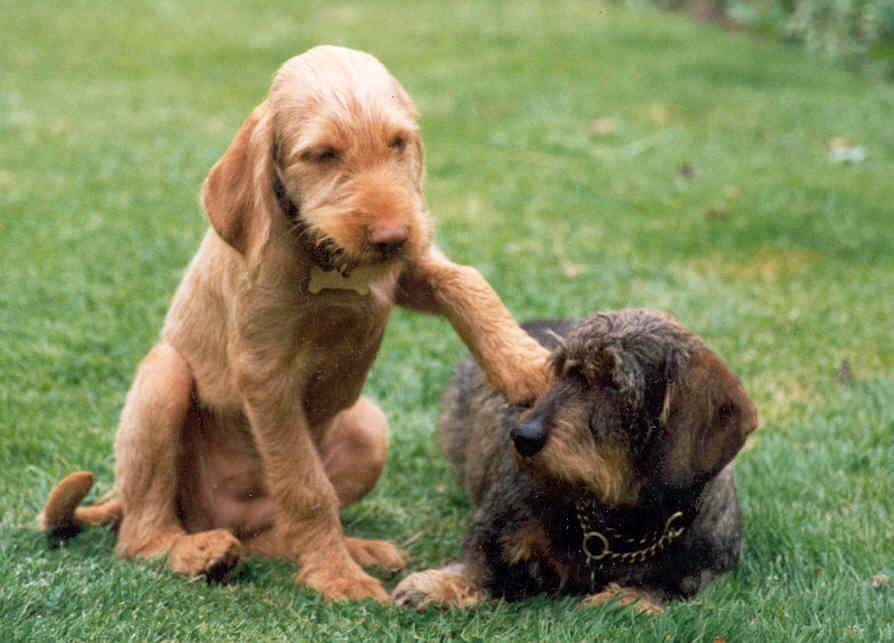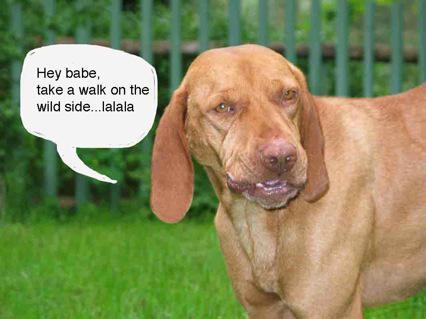The first image is the image on the left, the second image is the image on the right. Examine the images to the left and right. Is the description "In one image, a dog is carrying a stuffed animal in its mouth." accurate? Answer yes or no. No. 